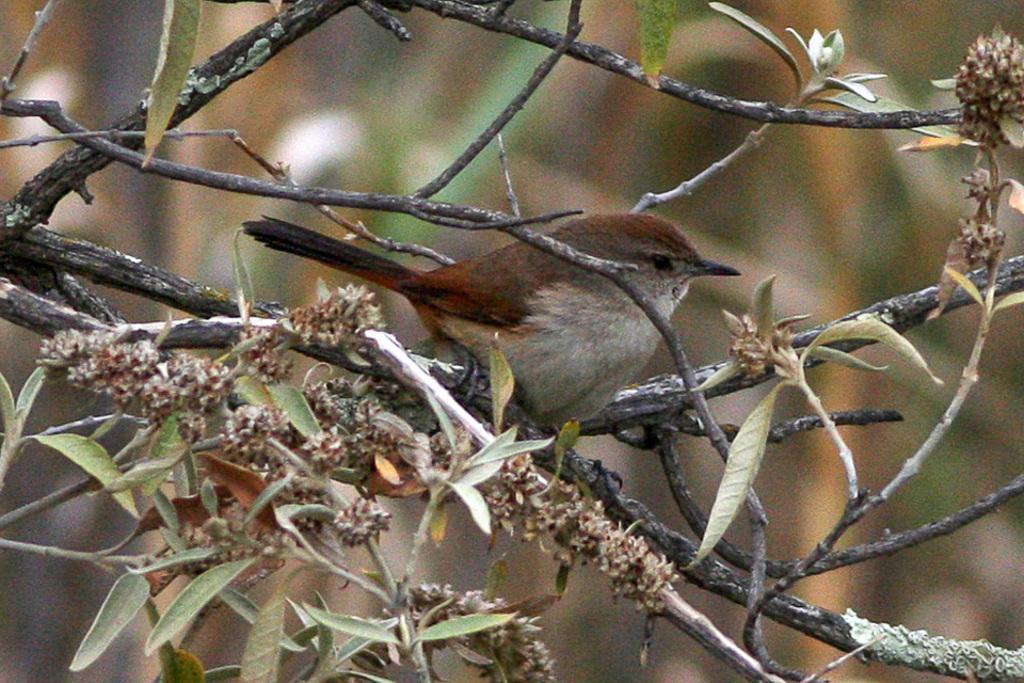Could you give a brief overview of what you see in this image? In this image we can see a bird is sitting on the branch of a tree and some leaves are their on the branch. 